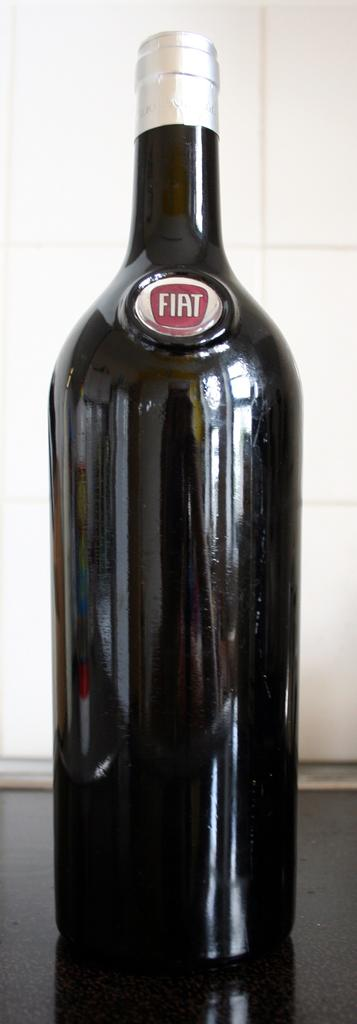<image>
Render a clear and concise summary of the photo. A dark colored wine bottle with a silver seal with the name Fiat on the front of the bottle. 